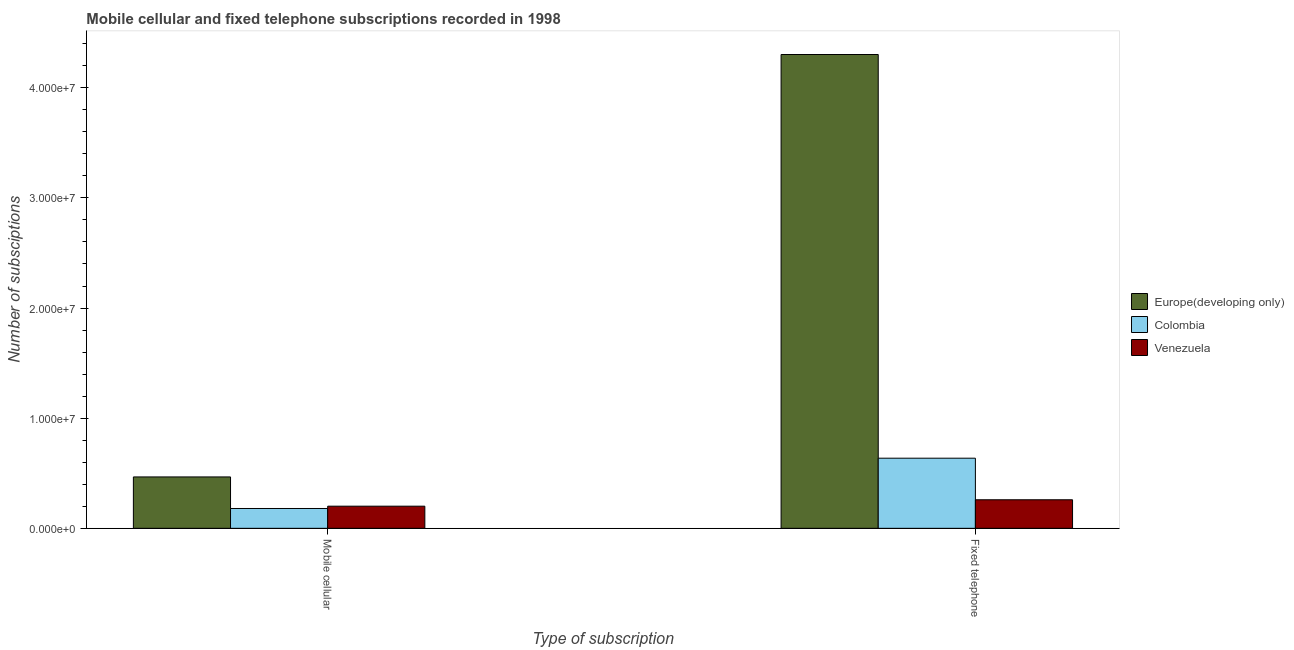Are the number of bars per tick equal to the number of legend labels?
Your response must be concise. Yes. Are the number of bars on each tick of the X-axis equal?
Make the answer very short. Yes. How many bars are there on the 2nd tick from the right?
Keep it short and to the point. 3. What is the label of the 2nd group of bars from the left?
Keep it short and to the point. Fixed telephone. What is the number of fixed telephone subscriptions in Venezuela?
Provide a succinct answer. 2.59e+06. Across all countries, what is the maximum number of mobile cellular subscriptions?
Your answer should be compact. 4.67e+06. Across all countries, what is the minimum number of fixed telephone subscriptions?
Offer a very short reply. 2.59e+06. In which country was the number of mobile cellular subscriptions maximum?
Offer a very short reply. Europe(developing only). In which country was the number of mobile cellular subscriptions minimum?
Your answer should be compact. Colombia. What is the total number of fixed telephone subscriptions in the graph?
Provide a succinct answer. 5.20e+07. What is the difference between the number of mobile cellular subscriptions in Venezuela and that in Colombia?
Keep it short and to the point. 2.10e+05. What is the difference between the number of mobile cellular subscriptions in Europe(developing only) and the number of fixed telephone subscriptions in Venezuela?
Make the answer very short. 2.07e+06. What is the average number of mobile cellular subscriptions per country?
Provide a succinct answer. 2.83e+06. What is the difference between the number of mobile cellular subscriptions and number of fixed telephone subscriptions in Venezuela?
Offer a very short reply. -5.83e+05. What is the ratio of the number of mobile cellular subscriptions in Europe(developing only) to that in Venezuela?
Your answer should be very brief. 2.32. In how many countries, is the number of fixed telephone subscriptions greater than the average number of fixed telephone subscriptions taken over all countries?
Keep it short and to the point. 1. What does the 2nd bar from the right in Fixed telephone represents?
Offer a very short reply. Colombia. Are all the bars in the graph horizontal?
Provide a succinct answer. No. How are the legend labels stacked?
Your response must be concise. Vertical. What is the title of the graph?
Offer a terse response. Mobile cellular and fixed telephone subscriptions recorded in 1998. Does "Cyprus" appear as one of the legend labels in the graph?
Offer a very short reply. No. What is the label or title of the X-axis?
Make the answer very short. Type of subscription. What is the label or title of the Y-axis?
Give a very brief answer. Number of subsciptions. What is the Number of subsciptions of Europe(developing only) in Mobile cellular?
Your answer should be compact. 4.67e+06. What is the Number of subsciptions of Colombia in Mobile cellular?
Your response must be concise. 1.80e+06. What is the Number of subsciptions in Venezuela in Mobile cellular?
Your response must be concise. 2.01e+06. What is the Number of subsciptions in Europe(developing only) in Fixed telephone?
Keep it short and to the point. 4.30e+07. What is the Number of subsciptions of Colombia in Fixed telephone?
Provide a short and direct response. 6.37e+06. What is the Number of subsciptions in Venezuela in Fixed telephone?
Provide a succinct answer. 2.59e+06. Across all Type of subscription, what is the maximum Number of subsciptions in Europe(developing only)?
Offer a terse response. 4.30e+07. Across all Type of subscription, what is the maximum Number of subsciptions of Colombia?
Your answer should be very brief. 6.37e+06. Across all Type of subscription, what is the maximum Number of subsciptions in Venezuela?
Your response must be concise. 2.59e+06. Across all Type of subscription, what is the minimum Number of subsciptions in Europe(developing only)?
Offer a very short reply. 4.67e+06. Across all Type of subscription, what is the minimum Number of subsciptions in Colombia?
Give a very brief answer. 1.80e+06. Across all Type of subscription, what is the minimum Number of subsciptions in Venezuela?
Offer a terse response. 2.01e+06. What is the total Number of subsciptions of Europe(developing only) in the graph?
Give a very brief answer. 4.77e+07. What is the total Number of subsciptions in Colombia in the graph?
Offer a terse response. 8.17e+06. What is the total Number of subsciptions in Venezuela in the graph?
Offer a very short reply. 4.60e+06. What is the difference between the Number of subsciptions in Europe(developing only) in Mobile cellular and that in Fixed telephone?
Ensure brevity in your answer.  -3.84e+07. What is the difference between the Number of subsciptions in Colombia in Mobile cellular and that in Fixed telephone?
Make the answer very short. -4.57e+06. What is the difference between the Number of subsciptions of Venezuela in Mobile cellular and that in Fixed telephone?
Your answer should be very brief. -5.83e+05. What is the difference between the Number of subsciptions of Europe(developing only) in Mobile cellular and the Number of subsciptions of Colombia in Fixed telephone?
Offer a very short reply. -1.70e+06. What is the difference between the Number of subsciptions in Europe(developing only) in Mobile cellular and the Number of subsciptions in Venezuela in Fixed telephone?
Keep it short and to the point. 2.07e+06. What is the difference between the Number of subsciptions in Colombia in Mobile cellular and the Number of subsciptions in Venezuela in Fixed telephone?
Make the answer very short. -7.92e+05. What is the average Number of subsciptions in Europe(developing only) per Type of subscription?
Ensure brevity in your answer.  2.38e+07. What is the average Number of subsciptions in Colombia per Type of subscription?
Provide a short and direct response. 4.08e+06. What is the average Number of subsciptions of Venezuela per Type of subscription?
Provide a short and direct response. 2.30e+06. What is the difference between the Number of subsciptions in Europe(developing only) and Number of subsciptions in Colombia in Mobile cellular?
Ensure brevity in your answer.  2.87e+06. What is the difference between the Number of subsciptions of Europe(developing only) and Number of subsciptions of Venezuela in Mobile cellular?
Your answer should be compact. 2.66e+06. What is the difference between the Number of subsciptions in Colombia and Number of subsciptions in Venezuela in Mobile cellular?
Make the answer very short. -2.10e+05. What is the difference between the Number of subsciptions in Europe(developing only) and Number of subsciptions in Colombia in Fixed telephone?
Ensure brevity in your answer.  3.67e+07. What is the difference between the Number of subsciptions of Europe(developing only) and Number of subsciptions of Venezuela in Fixed telephone?
Provide a succinct answer. 4.04e+07. What is the difference between the Number of subsciptions of Colombia and Number of subsciptions of Venezuela in Fixed telephone?
Provide a succinct answer. 3.77e+06. What is the ratio of the Number of subsciptions in Europe(developing only) in Mobile cellular to that in Fixed telephone?
Offer a terse response. 0.11. What is the ratio of the Number of subsciptions of Colombia in Mobile cellular to that in Fixed telephone?
Keep it short and to the point. 0.28. What is the ratio of the Number of subsciptions of Venezuela in Mobile cellular to that in Fixed telephone?
Make the answer very short. 0.78. What is the difference between the highest and the second highest Number of subsciptions in Europe(developing only)?
Give a very brief answer. 3.84e+07. What is the difference between the highest and the second highest Number of subsciptions of Colombia?
Offer a terse response. 4.57e+06. What is the difference between the highest and the second highest Number of subsciptions in Venezuela?
Ensure brevity in your answer.  5.83e+05. What is the difference between the highest and the lowest Number of subsciptions in Europe(developing only)?
Your answer should be compact. 3.84e+07. What is the difference between the highest and the lowest Number of subsciptions of Colombia?
Keep it short and to the point. 4.57e+06. What is the difference between the highest and the lowest Number of subsciptions in Venezuela?
Offer a very short reply. 5.83e+05. 